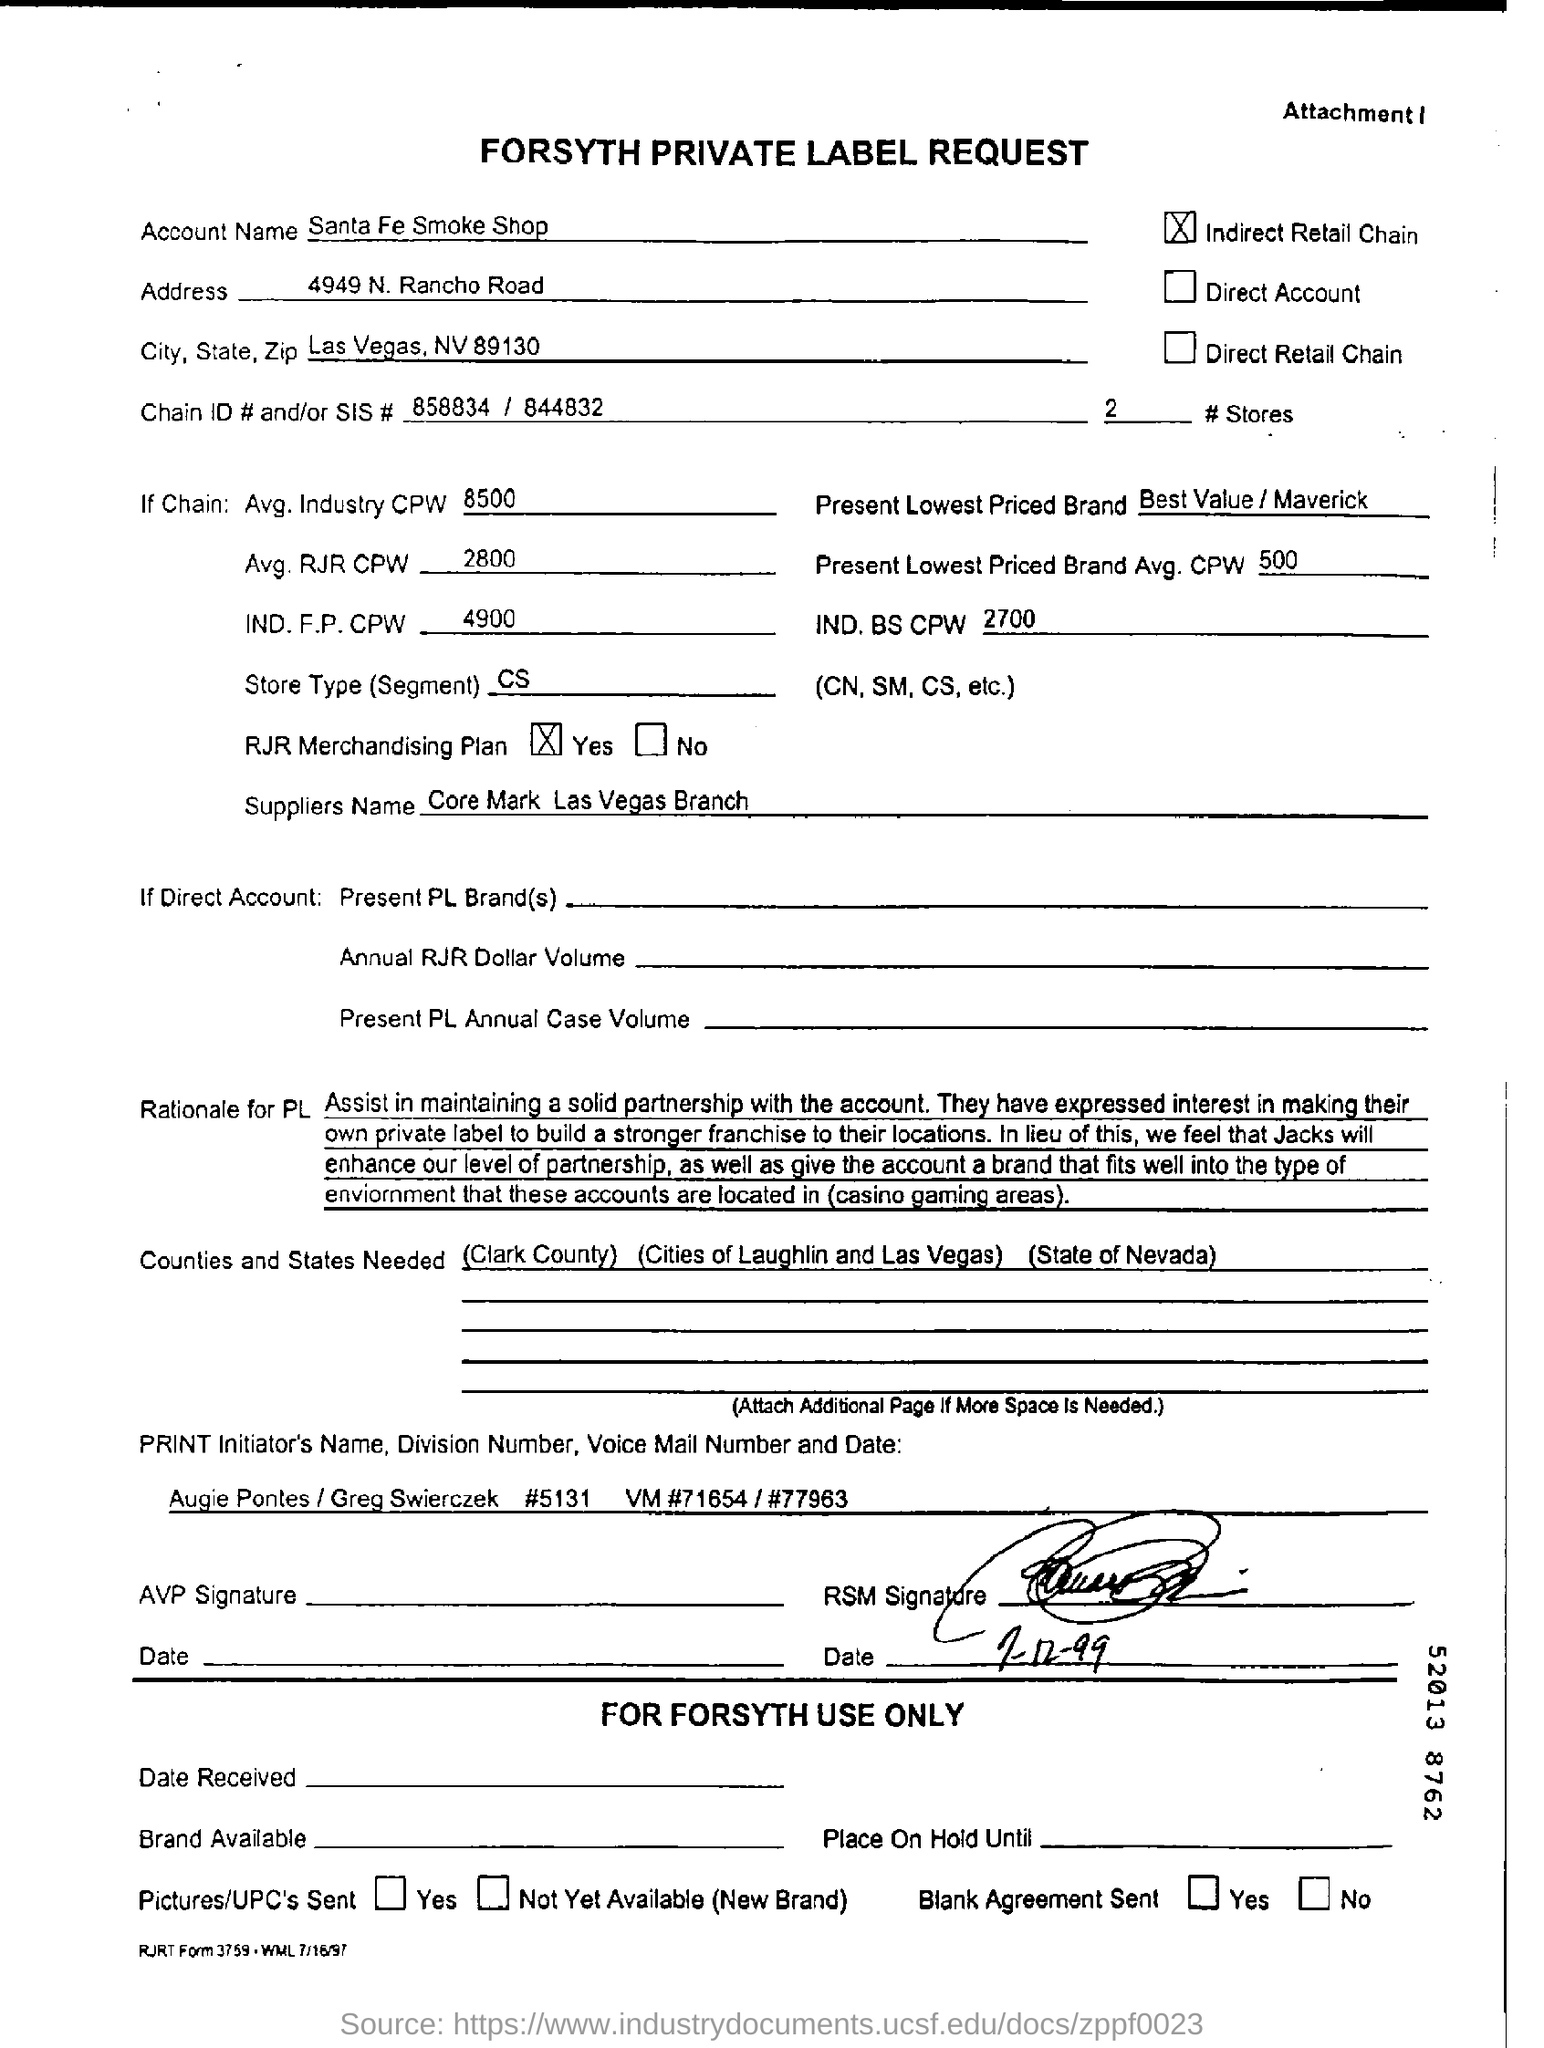Mention a couple of crucial points in this snapshot. The account name is Santa Fe Smoke Shop. The document title is "What is the document title? Forsyth Private Label Request..". 